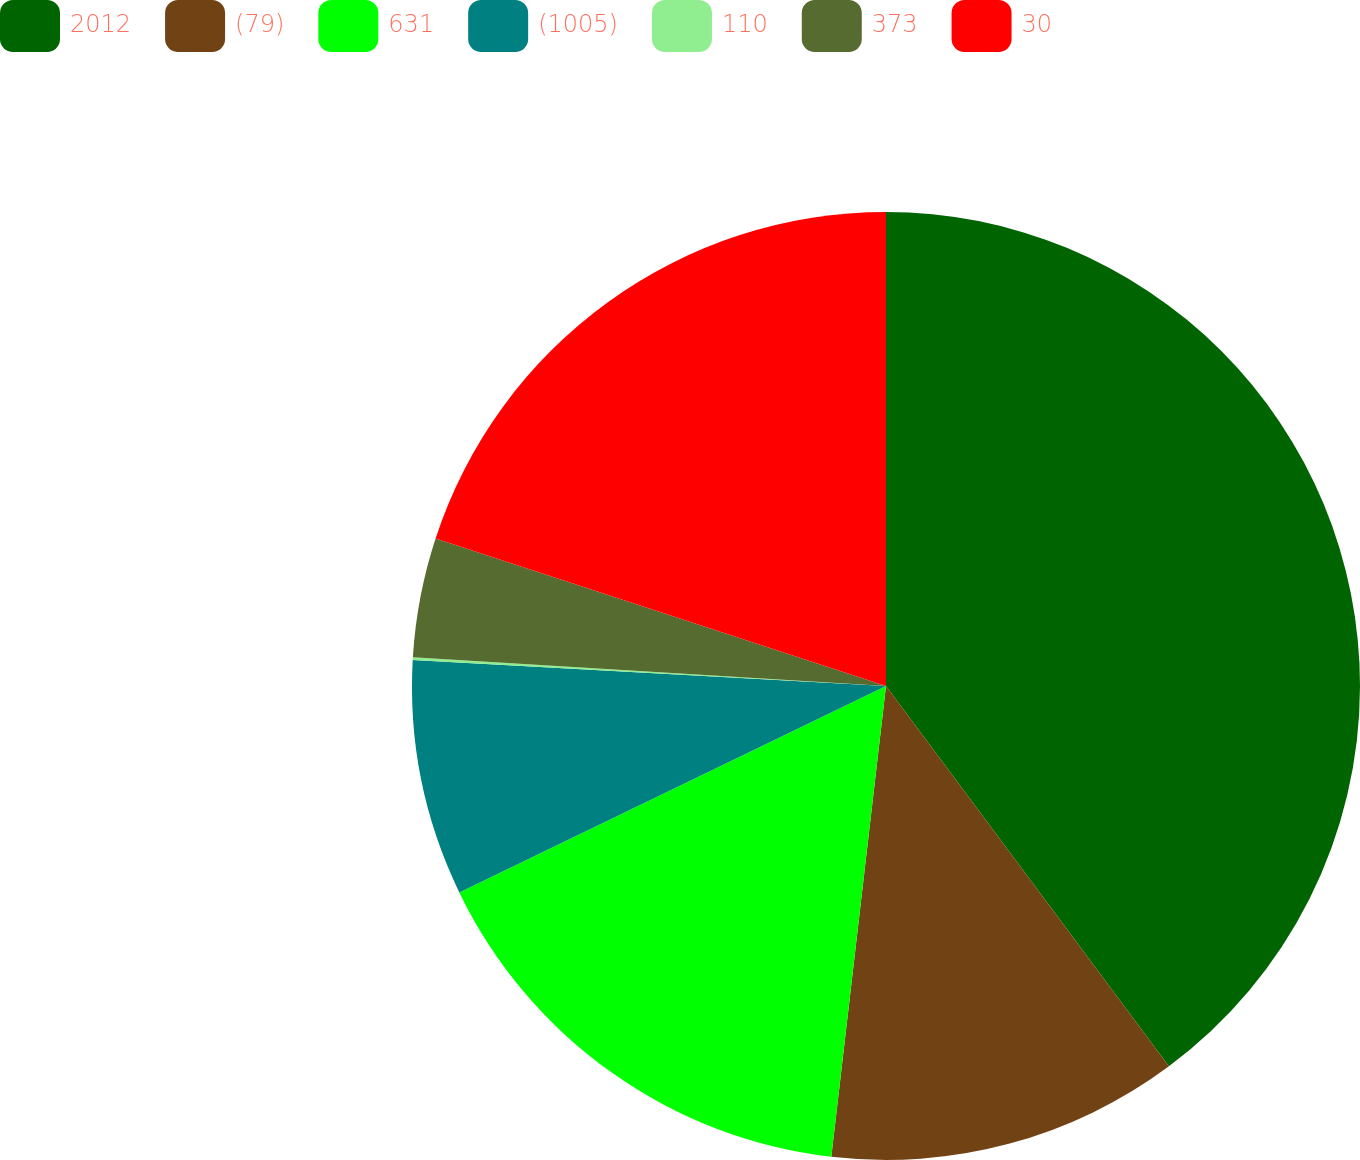Convert chart. <chart><loc_0><loc_0><loc_500><loc_500><pie_chart><fcel>2012<fcel>(79)<fcel>631<fcel>(1005)<fcel>110<fcel>373<fcel>30<nl><fcel>39.82%<fcel>12.02%<fcel>15.99%<fcel>8.04%<fcel>0.1%<fcel>4.07%<fcel>19.96%<nl></chart> 